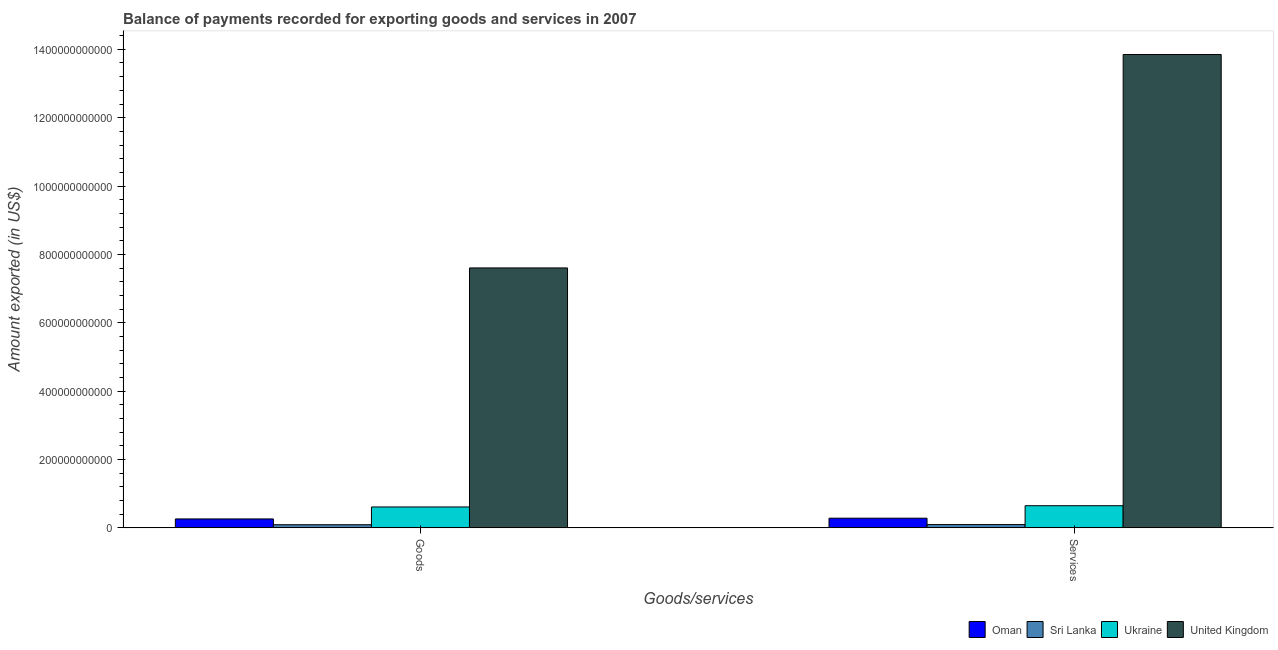How many different coloured bars are there?
Your answer should be compact. 4. How many bars are there on the 1st tick from the left?
Make the answer very short. 4. How many bars are there on the 2nd tick from the right?
Keep it short and to the point. 4. What is the label of the 2nd group of bars from the left?
Provide a succinct answer. Services. What is the amount of services exported in Oman?
Your response must be concise. 2.85e+1. Across all countries, what is the maximum amount of goods exported?
Your answer should be compact. 7.61e+11. Across all countries, what is the minimum amount of goods exported?
Your answer should be very brief. 9.41e+09. In which country was the amount of goods exported maximum?
Keep it short and to the point. United Kingdom. In which country was the amount of services exported minimum?
Provide a short and direct response. Sri Lanka. What is the total amount of goods exported in the graph?
Ensure brevity in your answer.  8.58e+11. What is the difference between the amount of goods exported in Sri Lanka and that in Oman?
Your answer should be very brief. -1.70e+1. What is the difference between the amount of services exported in Ukraine and the amount of goods exported in Sri Lanka?
Your answer should be very brief. 5.57e+1. What is the average amount of goods exported per country?
Your answer should be compact. 2.14e+11. What is the difference between the amount of services exported and amount of goods exported in United Kingdom?
Provide a short and direct response. 6.24e+11. What is the ratio of the amount of services exported in Ukraine to that in Sri Lanka?
Offer a terse response. 6.6. Is the amount of goods exported in United Kingdom less than that in Ukraine?
Ensure brevity in your answer.  No. In how many countries, is the amount of services exported greater than the average amount of services exported taken over all countries?
Your response must be concise. 1. What does the 3rd bar from the left in Services represents?
Offer a very short reply. Ukraine. What does the 2nd bar from the right in Services represents?
Give a very brief answer. Ukraine. What is the difference between two consecutive major ticks on the Y-axis?
Make the answer very short. 2.00e+11. Are the values on the major ticks of Y-axis written in scientific E-notation?
Make the answer very short. No. How are the legend labels stacked?
Your response must be concise. Horizontal. What is the title of the graph?
Offer a very short reply. Balance of payments recorded for exporting goods and services in 2007. What is the label or title of the X-axis?
Ensure brevity in your answer.  Goods/services. What is the label or title of the Y-axis?
Provide a short and direct response. Amount exported (in US$). What is the Amount exported (in US$) of Oman in Goods?
Offer a very short reply. 2.64e+1. What is the Amount exported (in US$) in Sri Lanka in Goods?
Provide a succinct answer. 9.41e+09. What is the Amount exported (in US$) in Ukraine in Goods?
Provide a short and direct response. 6.14e+1. What is the Amount exported (in US$) in United Kingdom in Goods?
Offer a very short reply. 7.61e+11. What is the Amount exported (in US$) in Oman in Services?
Provide a succinct answer. 2.85e+1. What is the Amount exported (in US$) in Sri Lanka in Services?
Offer a very short reply. 9.86e+09. What is the Amount exported (in US$) in Ukraine in Services?
Provide a succinct answer. 6.51e+1. What is the Amount exported (in US$) of United Kingdom in Services?
Offer a terse response. 1.38e+12. Across all Goods/services, what is the maximum Amount exported (in US$) in Oman?
Your response must be concise. 2.85e+1. Across all Goods/services, what is the maximum Amount exported (in US$) of Sri Lanka?
Your response must be concise. 9.86e+09. Across all Goods/services, what is the maximum Amount exported (in US$) in Ukraine?
Provide a succinct answer. 6.51e+1. Across all Goods/services, what is the maximum Amount exported (in US$) in United Kingdom?
Offer a terse response. 1.38e+12. Across all Goods/services, what is the minimum Amount exported (in US$) in Oman?
Provide a short and direct response. 2.64e+1. Across all Goods/services, what is the minimum Amount exported (in US$) in Sri Lanka?
Ensure brevity in your answer.  9.41e+09. Across all Goods/services, what is the minimum Amount exported (in US$) in Ukraine?
Your answer should be compact. 6.14e+1. Across all Goods/services, what is the minimum Amount exported (in US$) in United Kingdom?
Offer a terse response. 7.61e+11. What is the total Amount exported (in US$) in Oman in the graph?
Make the answer very short. 5.49e+1. What is the total Amount exported (in US$) in Sri Lanka in the graph?
Ensure brevity in your answer.  1.93e+1. What is the total Amount exported (in US$) of Ukraine in the graph?
Provide a short and direct response. 1.26e+11. What is the total Amount exported (in US$) in United Kingdom in the graph?
Provide a short and direct response. 2.15e+12. What is the difference between the Amount exported (in US$) of Oman in Goods and that in Services?
Your answer should be compact. -2.16e+09. What is the difference between the Amount exported (in US$) in Sri Lanka in Goods and that in Services?
Your answer should be very brief. -4.49e+08. What is the difference between the Amount exported (in US$) of Ukraine in Goods and that in Services?
Provide a short and direct response. -3.66e+09. What is the difference between the Amount exported (in US$) in United Kingdom in Goods and that in Services?
Give a very brief answer. -6.24e+11. What is the difference between the Amount exported (in US$) of Oman in Goods and the Amount exported (in US$) of Sri Lanka in Services?
Provide a succinct answer. 1.65e+1. What is the difference between the Amount exported (in US$) in Oman in Goods and the Amount exported (in US$) in Ukraine in Services?
Your answer should be very brief. -3.87e+1. What is the difference between the Amount exported (in US$) of Oman in Goods and the Amount exported (in US$) of United Kingdom in Services?
Keep it short and to the point. -1.36e+12. What is the difference between the Amount exported (in US$) in Sri Lanka in Goods and the Amount exported (in US$) in Ukraine in Services?
Offer a terse response. -5.57e+1. What is the difference between the Amount exported (in US$) in Sri Lanka in Goods and the Amount exported (in US$) in United Kingdom in Services?
Offer a very short reply. -1.38e+12. What is the difference between the Amount exported (in US$) in Ukraine in Goods and the Amount exported (in US$) in United Kingdom in Services?
Provide a succinct answer. -1.32e+12. What is the average Amount exported (in US$) in Oman per Goods/services?
Provide a short and direct response. 2.75e+1. What is the average Amount exported (in US$) of Sri Lanka per Goods/services?
Provide a short and direct response. 9.64e+09. What is the average Amount exported (in US$) of Ukraine per Goods/services?
Your answer should be compact. 6.32e+1. What is the average Amount exported (in US$) of United Kingdom per Goods/services?
Your response must be concise. 1.07e+12. What is the difference between the Amount exported (in US$) in Oman and Amount exported (in US$) in Sri Lanka in Goods?
Keep it short and to the point. 1.70e+1. What is the difference between the Amount exported (in US$) of Oman and Amount exported (in US$) of Ukraine in Goods?
Offer a terse response. -3.50e+1. What is the difference between the Amount exported (in US$) in Oman and Amount exported (in US$) in United Kingdom in Goods?
Ensure brevity in your answer.  -7.34e+11. What is the difference between the Amount exported (in US$) in Sri Lanka and Amount exported (in US$) in Ukraine in Goods?
Your answer should be compact. -5.20e+1. What is the difference between the Amount exported (in US$) in Sri Lanka and Amount exported (in US$) in United Kingdom in Goods?
Provide a short and direct response. -7.51e+11. What is the difference between the Amount exported (in US$) in Ukraine and Amount exported (in US$) in United Kingdom in Goods?
Give a very brief answer. -6.99e+11. What is the difference between the Amount exported (in US$) of Oman and Amount exported (in US$) of Sri Lanka in Services?
Provide a succinct answer. 1.87e+1. What is the difference between the Amount exported (in US$) of Oman and Amount exported (in US$) of Ukraine in Services?
Provide a short and direct response. -3.65e+1. What is the difference between the Amount exported (in US$) of Oman and Amount exported (in US$) of United Kingdom in Services?
Give a very brief answer. -1.36e+12. What is the difference between the Amount exported (in US$) of Sri Lanka and Amount exported (in US$) of Ukraine in Services?
Provide a succinct answer. -5.52e+1. What is the difference between the Amount exported (in US$) in Sri Lanka and Amount exported (in US$) in United Kingdom in Services?
Provide a short and direct response. -1.37e+12. What is the difference between the Amount exported (in US$) of Ukraine and Amount exported (in US$) of United Kingdom in Services?
Offer a very short reply. -1.32e+12. What is the ratio of the Amount exported (in US$) of Oman in Goods to that in Services?
Give a very brief answer. 0.92. What is the ratio of the Amount exported (in US$) of Sri Lanka in Goods to that in Services?
Your response must be concise. 0.95. What is the ratio of the Amount exported (in US$) in Ukraine in Goods to that in Services?
Make the answer very short. 0.94. What is the ratio of the Amount exported (in US$) of United Kingdom in Goods to that in Services?
Your response must be concise. 0.55. What is the difference between the highest and the second highest Amount exported (in US$) of Oman?
Offer a terse response. 2.16e+09. What is the difference between the highest and the second highest Amount exported (in US$) of Sri Lanka?
Provide a short and direct response. 4.49e+08. What is the difference between the highest and the second highest Amount exported (in US$) of Ukraine?
Your answer should be compact. 3.66e+09. What is the difference between the highest and the second highest Amount exported (in US$) of United Kingdom?
Give a very brief answer. 6.24e+11. What is the difference between the highest and the lowest Amount exported (in US$) of Oman?
Your answer should be compact. 2.16e+09. What is the difference between the highest and the lowest Amount exported (in US$) of Sri Lanka?
Your response must be concise. 4.49e+08. What is the difference between the highest and the lowest Amount exported (in US$) of Ukraine?
Your response must be concise. 3.66e+09. What is the difference between the highest and the lowest Amount exported (in US$) in United Kingdom?
Ensure brevity in your answer.  6.24e+11. 